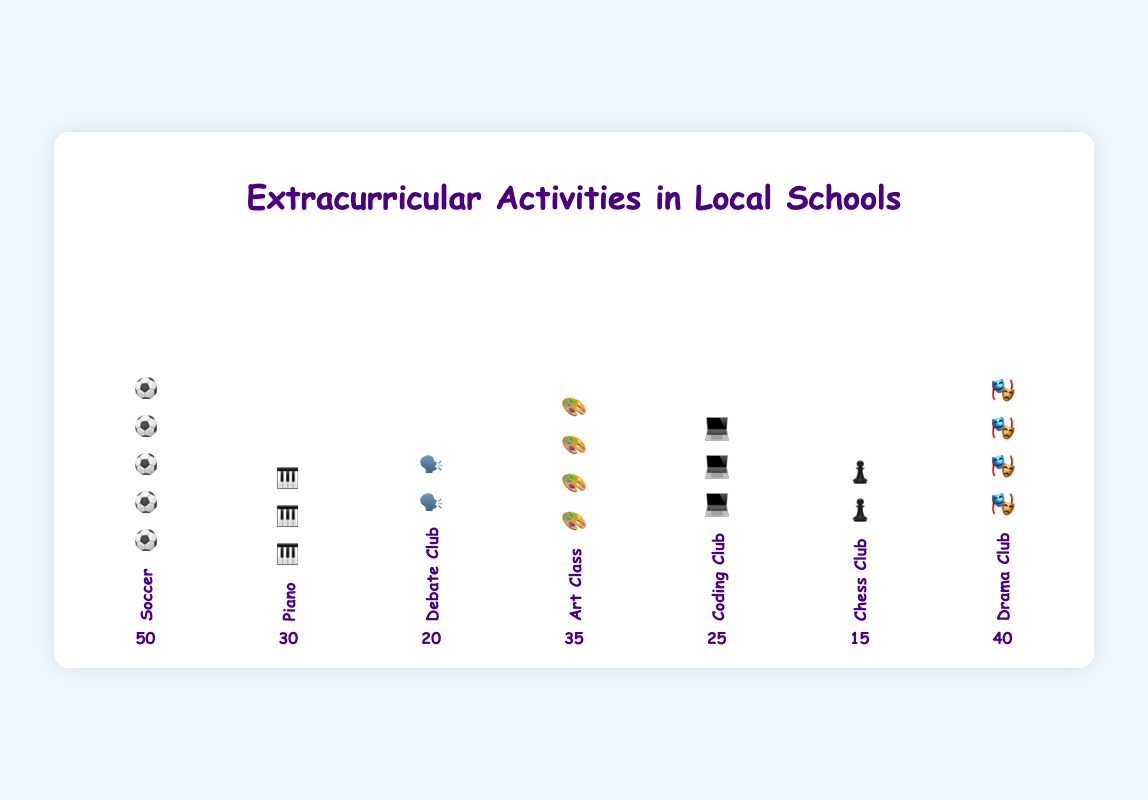What is the total number of participants in the Drama Club? Look at the "Drama Club" column in the figure. Count the total number of icons and read the participants label for verification.
Answer: 40 Which activity has the least number of participants? Survey all columns and compare participant counts. Find the one with the smallest number.
Answer: Chess Club How many more participants does Soccer have compared to Debate Club? Subtract the number of participants in Debate Club from those in Soccer: 50 - 20 = 30.
Answer: 30 What is the total number of participants across all activities? Sum the number of participants in each activity: 50 + 30 + 20 + 35 + 25 + 15 + 40 = 215.
Answer: 215 List activities with more than 30 participants. Compare each activity's participant number to 30 and list those greater: Soccer, Piano, Art Class, Drama Club.
Answer: Soccer, Piano, Art Class, Drama Club Which activities have the same number of participants? Identify and compare the participant numbers of each activity. Soccer and Soccer appear three times.
Answer: None Which activity has the second highest number of participants? Arrange activities by participant numbers and find the second largest: Soccer (50) and then Drama Club (40).
Answer: Drama Club What's the difference in the number of participants between Art Class and Chess Club? Subtract the number of participants in Chess Club from Art Class: 35 - 15 = 20.
Answer: 20 Compare the number of participants in Coding Club and Piano. Which has more, and by how much? Identify and compare participant numbers of each activity. Piano has 30 participants while Coding Club has 25. The difference is 30 - 25 = 5.
Answer: Piano, 5 What's the average number of participants per activity? Sum the number of participants and divide by the number of activities: 215 / 7 ≈ 30.71.
Answer: 30.71 